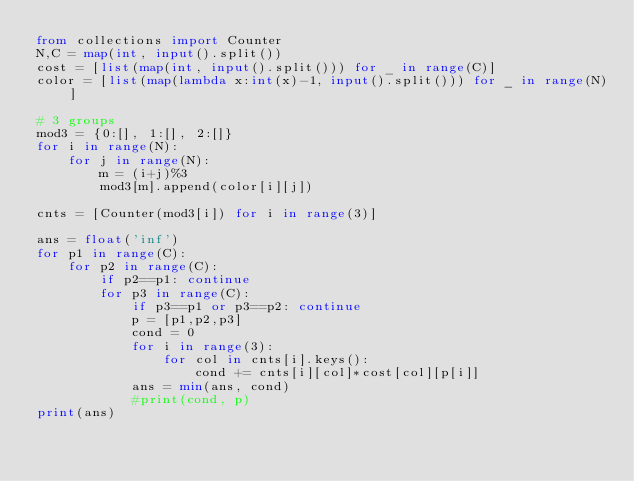<code> <loc_0><loc_0><loc_500><loc_500><_Python_>from collections import Counter
N,C = map(int, input().split())
cost = [list(map(int, input().split())) for _ in range(C)]
color = [list(map(lambda x:int(x)-1, input().split())) for _ in range(N)]

# 3 groups
mod3 = {0:[], 1:[], 2:[]}
for i in range(N):
    for j in range(N):
        m = (i+j)%3
        mod3[m].append(color[i][j])

cnts = [Counter(mod3[i]) for i in range(3)]

ans = float('inf')
for p1 in range(C):
    for p2 in range(C):
        if p2==p1: continue
        for p3 in range(C):
            if p3==p1 or p3==p2: continue
            p = [p1,p2,p3]
            cond = 0
            for i in range(3):
                for col in cnts[i].keys():
                    cond += cnts[i][col]*cost[col][p[i]]
            ans = min(ans, cond)
            #print(cond, p)
print(ans)
    </code> 